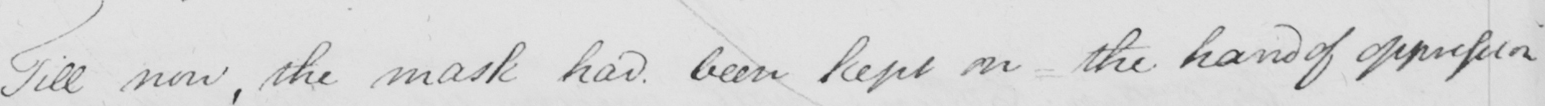What text is written in this handwritten line? Till now , the mask had been kept on  _  the hand of oppression 